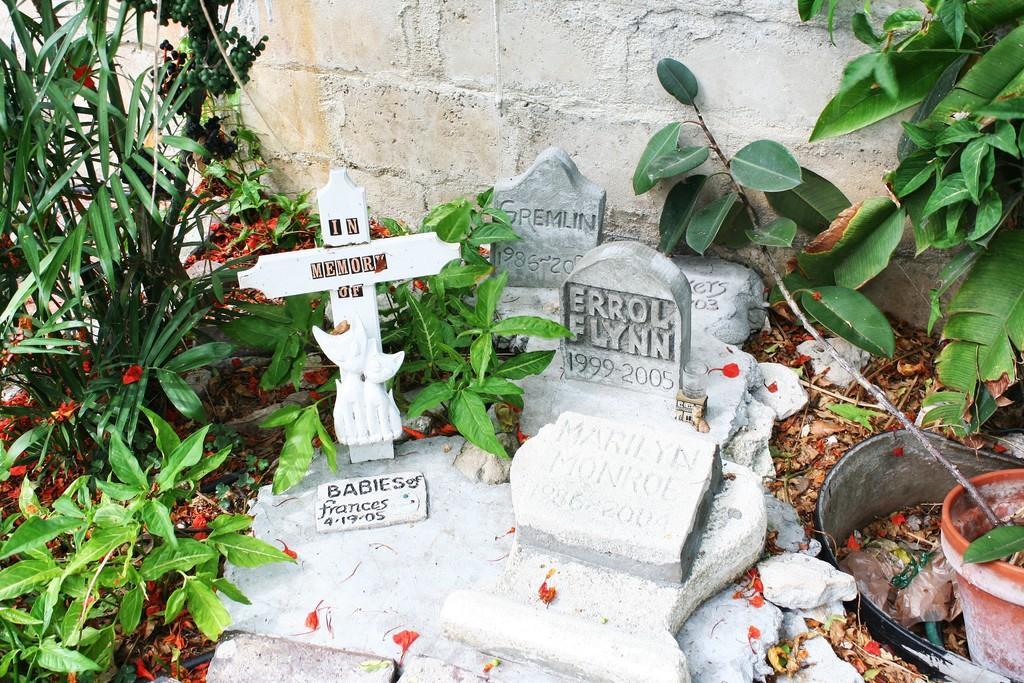Could you give a brief overview of what you see in this image? In the center of the image there are graveyard stones with text on it. There is cross symbol with some text. In the background of the image there is wall. To the both sides of the image there are plants. To the right side of the image there is flower pot. 